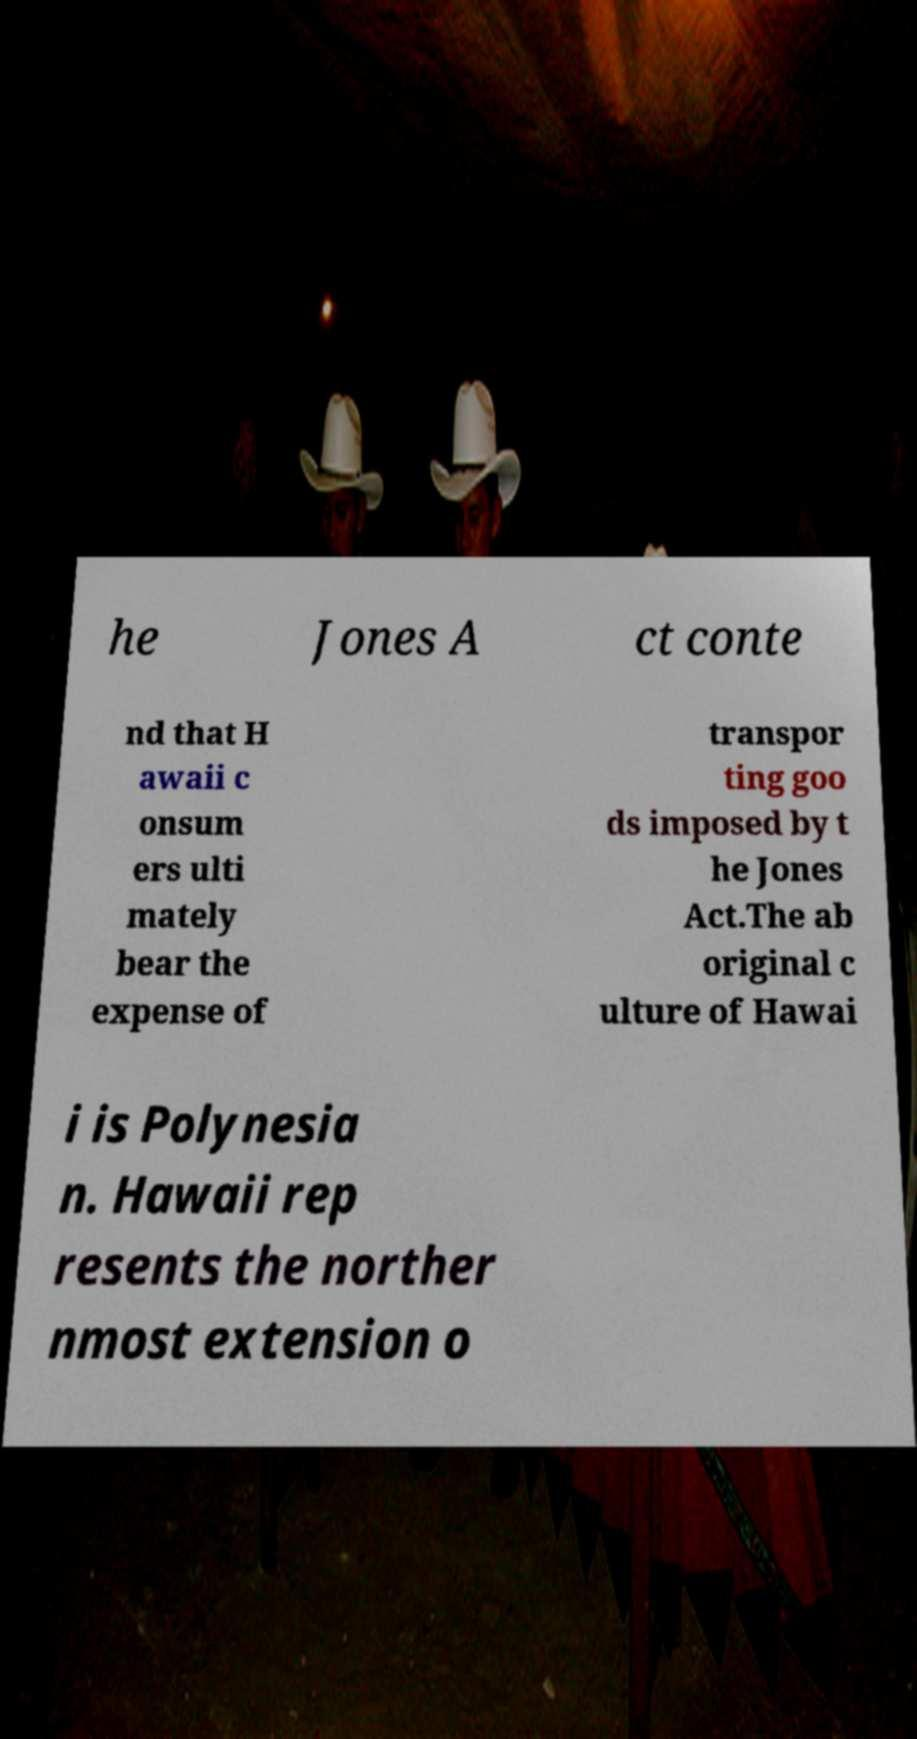Please read and relay the text visible in this image. What does it say? he Jones A ct conte nd that H awaii c onsum ers ulti mately bear the expense of transpor ting goo ds imposed by t he Jones Act.The ab original c ulture of Hawai i is Polynesia n. Hawaii rep resents the norther nmost extension o 